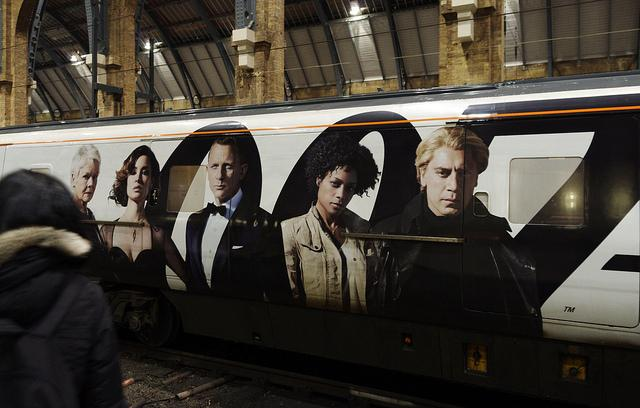Which franchise is advertised here? Please explain your reasoning. james bond. The franchise is bond. 